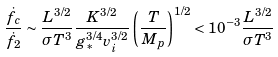<formula> <loc_0><loc_0><loc_500><loc_500>\frac { \dot { f } _ { c } } { \dot { f } _ { 2 } } \sim \frac { L ^ { 3 / 2 } } { \sigma T ^ { 3 } } \frac { K ^ { 3 / 2 } } { g _ { \ast } ^ { 3 / 4 } v _ { i } ^ { 3 / 2 } } \left ( \frac { T } { M _ { p } } \right ) ^ { 1 / 2 } < 1 0 ^ { - 3 } \frac { L ^ { 3 / 2 } } { \sigma T ^ { 3 } }</formula> 